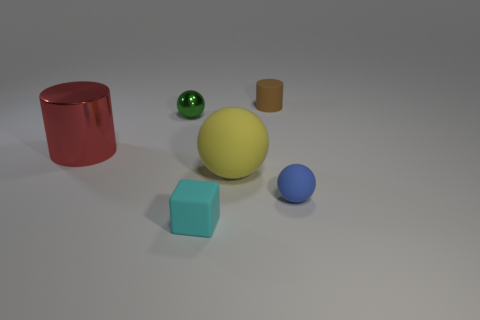Add 1 big blue rubber objects. How many objects exist? 7 Subtract all cylinders. How many objects are left? 4 Add 1 tiny green metal cylinders. How many tiny green metal cylinders exist? 1 Subtract 1 red cylinders. How many objects are left? 5 Subtract all large brown objects. Subtract all matte cylinders. How many objects are left? 5 Add 1 large things. How many large things are left? 3 